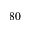<formula> <loc_0><loc_0><loc_500><loc_500>8 0</formula> 